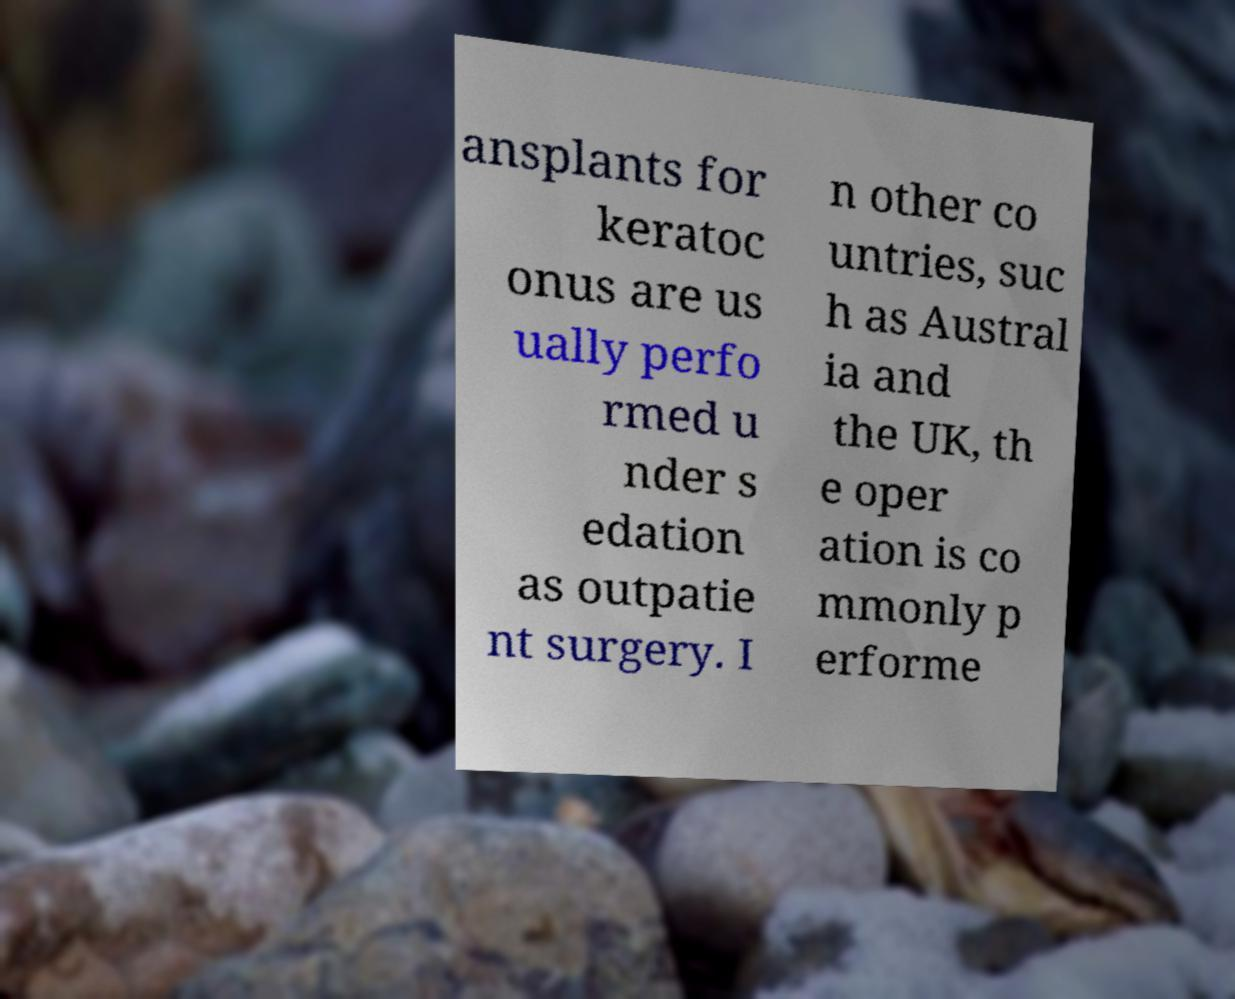Could you assist in decoding the text presented in this image and type it out clearly? ansplants for keratoc onus are us ually perfo rmed u nder s edation as outpatie nt surgery. I n other co untries, suc h as Austral ia and the UK, th e oper ation is co mmonly p erforme 